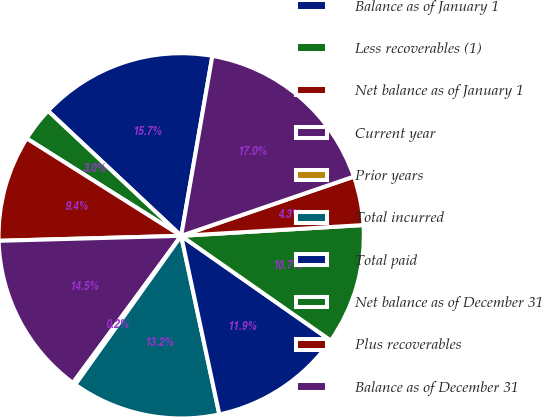Convert chart. <chart><loc_0><loc_0><loc_500><loc_500><pie_chart><fcel>Balance as of January 1<fcel>Less recoverables (1)<fcel>Net balance as of January 1<fcel>Current year<fcel>Prior years<fcel>Total incurred<fcel>Total paid<fcel>Net balance as of December 31<fcel>Plus recoverables<fcel>Balance as of December 31<nl><fcel>15.74%<fcel>3.04%<fcel>9.39%<fcel>14.47%<fcel>0.25%<fcel>13.2%<fcel>11.93%<fcel>10.66%<fcel>4.32%<fcel>17.01%<nl></chart> 